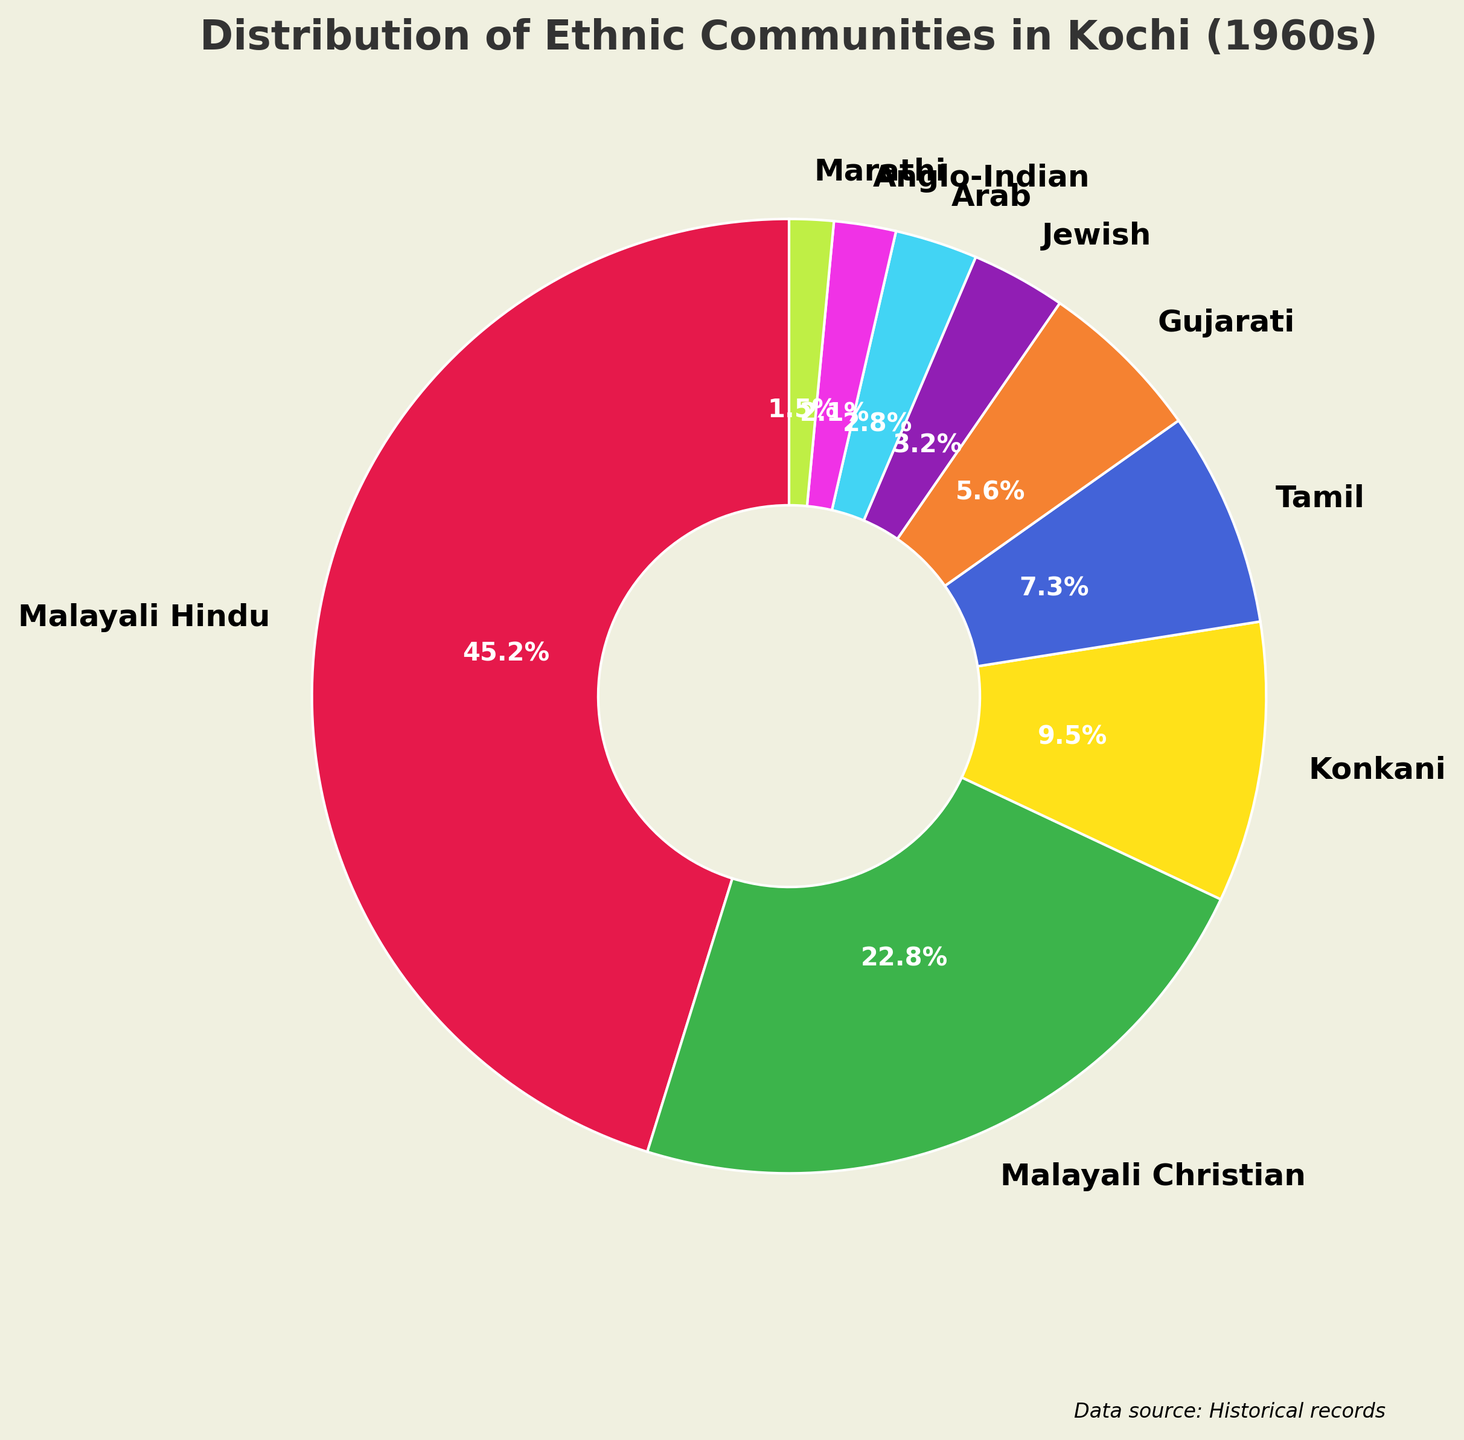which ethnic community has the largest proportion in Kochi during the 1960s? The pie chart shows different ethnic communities with their respective percentages. The largest portion is the Malayali Hindu community, occupying 45.2% of the pie.
Answer: Malayali Hindu which two communities together form a quarter of the population? The pie chart's percentages can be added to find which two communities together make 25%. The Anglo-Indian (2.1%) and Marathi (1.5%) together form 3.6%, which is too small. By summing the percentages, the Arab (2.8%) and Jewish (3.2%) communities together make up 6%, still too small. Adding the Gujarati (5.6%) and Tamil (7.3%) communities gives us 12.9%, which is closer but not quite there. Finally, the Malayali Christian (22.8%) and Konkani (9.5%) together equal 32.3%, which is incorrect. Therefore, there's no exact pair making 25%.
Answer: No exact pair What is the combined percentage of the smallest three ethnic communities? According to the pie chart, the smallest three communities are Marathi (1.5%), Anglo-Indian (2.1%), and Arab (2.8%). Summing these percentages: 1.5% + 2.1% + 2.8% = 6.4%.
Answer: 6.4% How much larger is the Malayali Hindu community compared to the Jewish community? The percentage for Malayali Hindu is 45.2% and for Jewish, it is 3.2%. Subtracting the percentages gives 45.2% - 3.2% = 42.0%.
Answer: 42.0% Which community has the light blue color in the pie chart? By referring to the colors assigned to each community in the pie chart, the Konkani community is represented by light blue.
Answer: Konkani what percentage of Kochi's population in the 1960s was neither Malayali Hindu nor Malayali Christian? The percentages for Malayali Hindu and Malayali Christian are 45.2% and 22.8% respectively. Summing these yields 68%. Subtracting this from 100% gives 100% - 68% = 32%.
Answer: 32% What is the ratio of the Gujaratis to Tamils in Kochi during the 1960s? The pie chart shows the Gujarati community at 5.6% and the Tamil community at 7.3%. The ratio is 5.6:7.3. Simplifying this ratio by dividing both by the greatest common divisor, which in this case is 1, gives roughly 5.6/7.3 ≈ 0.77.
Answer: ~0.77:1 (or simply, 5.6:7.3) What ethnic community has a proportion closest to a tenth of the total population? A tenth of the population is 10%. Referring to the chart, Konkani at 9.5% is closest to 10%.
Answer: Konkani 